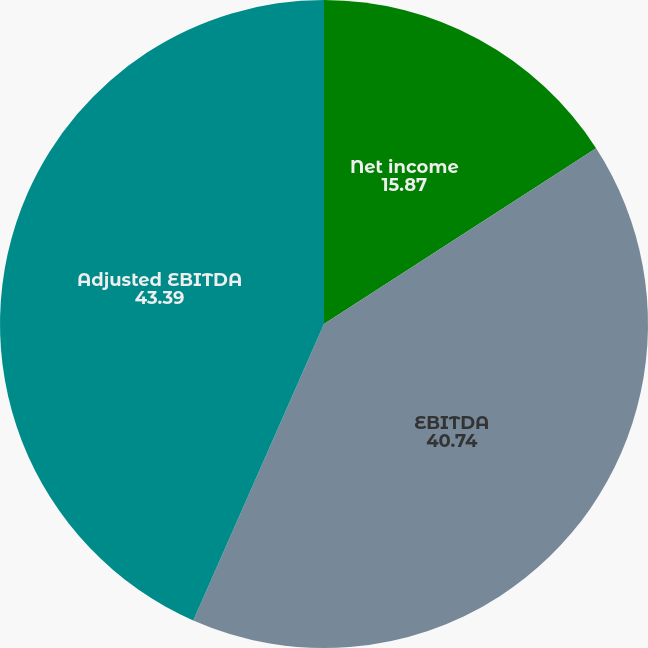Convert chart. <chart><loc_0><loc_0><loc_500><loc_500><pie_chart><fcel>Net income<fcel>EBITDA<fcel>Adjusted EBITDA<nl><fcel>15.87%<fcel>40.74%<fcel>43.39%<nl></chart> 